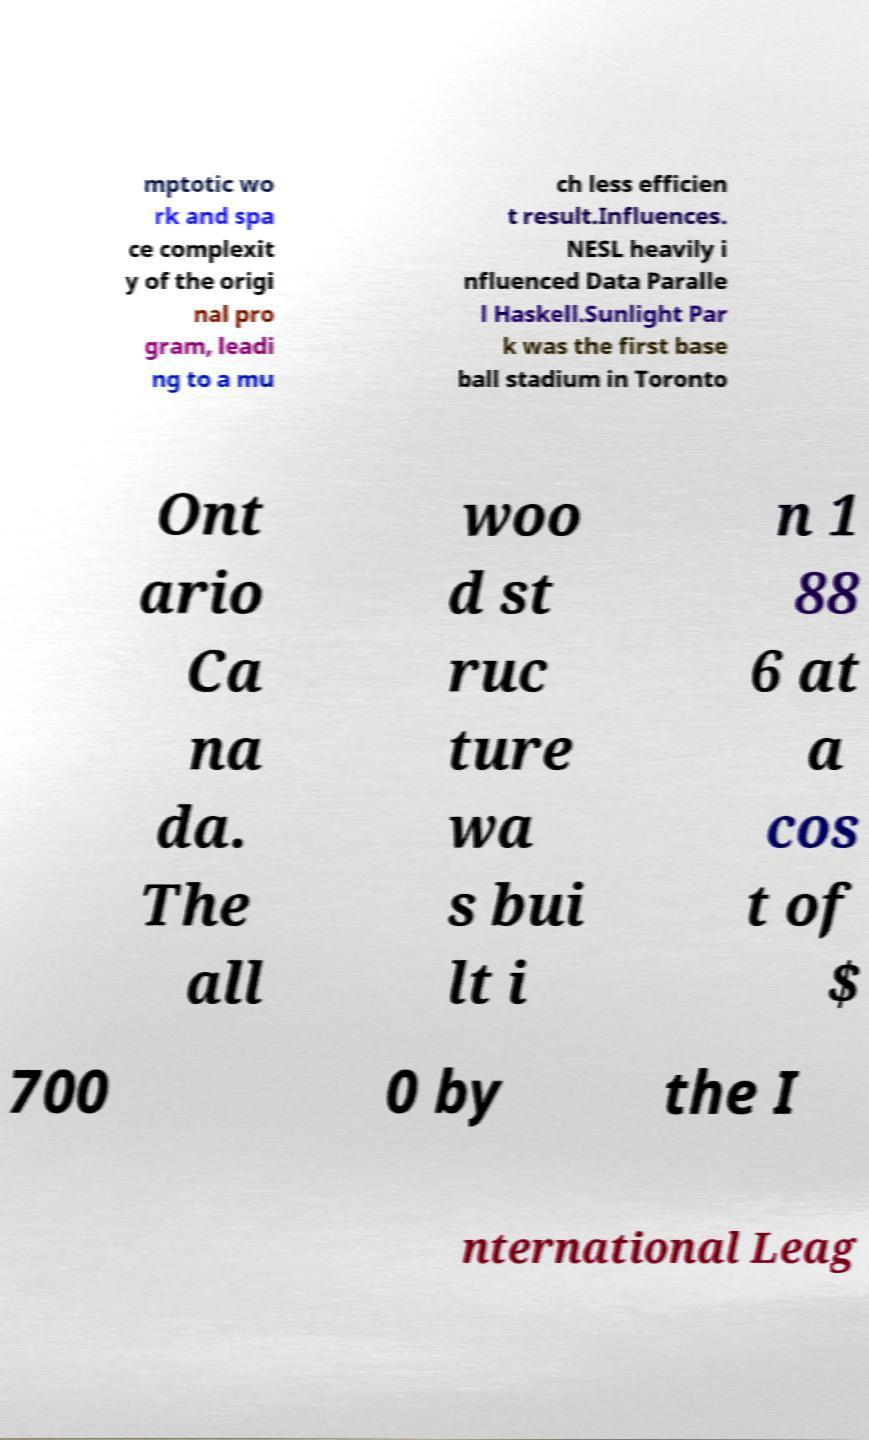Please read and relay the text visible in this image. What does it say? mptotic wo rk and spa ce complexit y of the origi nal pro gram, leadi ng to a mu ch less efficien t result.Influences. NESL heavily i nfluenced Data Paralle l Haskell.Sunlight Par k was the first base ball stadium in Toronto Ont ario Ca na da. The all woo d st ruc ture wa s bui lt i n 1 88 6 at a cos t of $ 700 0 by the I nternational Leag 